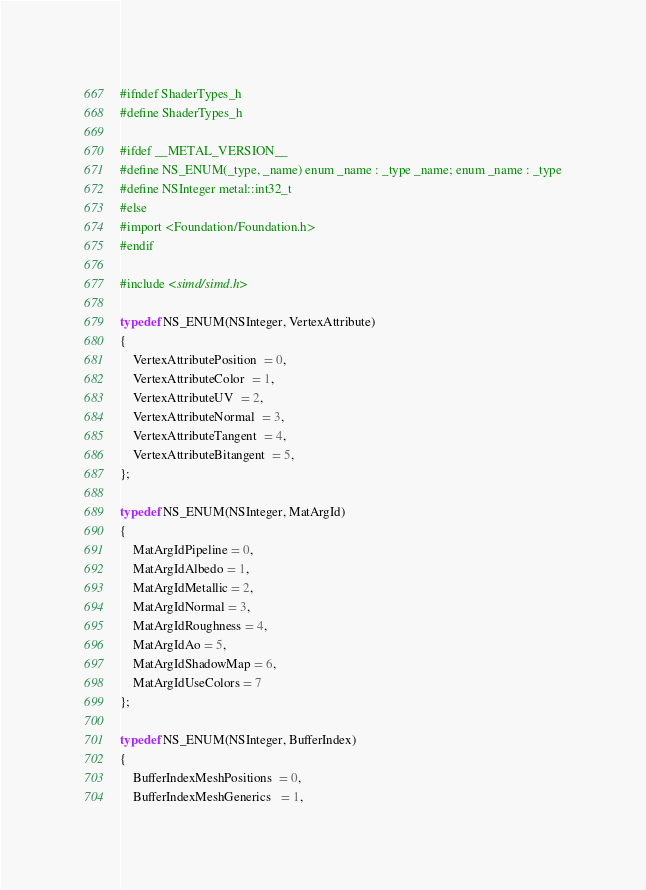Convert code to text. <code><loc_0><loc_0><loc_500><loc_500><_C_>
#ifndef ShaderTypes_h
#define ShaderTypes_h

#ifdef __METAL_VERSION__
#define NS_ENUM(_type, _name) enum _name : _type _name; enum _name : _type
#define NSInteger metal::int32_t
#else
#import <Foundation/Foundation.h>
#endif

#include <simd/simd.h>

typedef NS_ENUM(NSInteger, VertexAttribute)
{
	VertexAttributePosition  = 0,
	VertexAttributeColor  = 1,
	VertexAttributeUV  = 2,
	VertexAttributeNormal  = 3,
	VertexAttributeTangent  = 4,
	VertexAttributeBitangent  = 5,
};

typedef NS_ENUM(NSInteger, MatArgId)
{
	MatArgIdPipeline = 0,
	MatArgIdAlbedo = 1,
	MatArgIdMetallic = 2,
	MatArgIdNormal = 3,
	MatArgIdRoughness = 4,
	MatArgIdAo = 5,
	MatArgIdShadowMap = 6,
	MatArgIdUseColors = 7
};

typedef NS_ENUM(NSInteger, BufferIndex)
{
	BufferIndexMeshPositions  = 0,
	BufferIndexMeshGenerics   = 1,</code> 